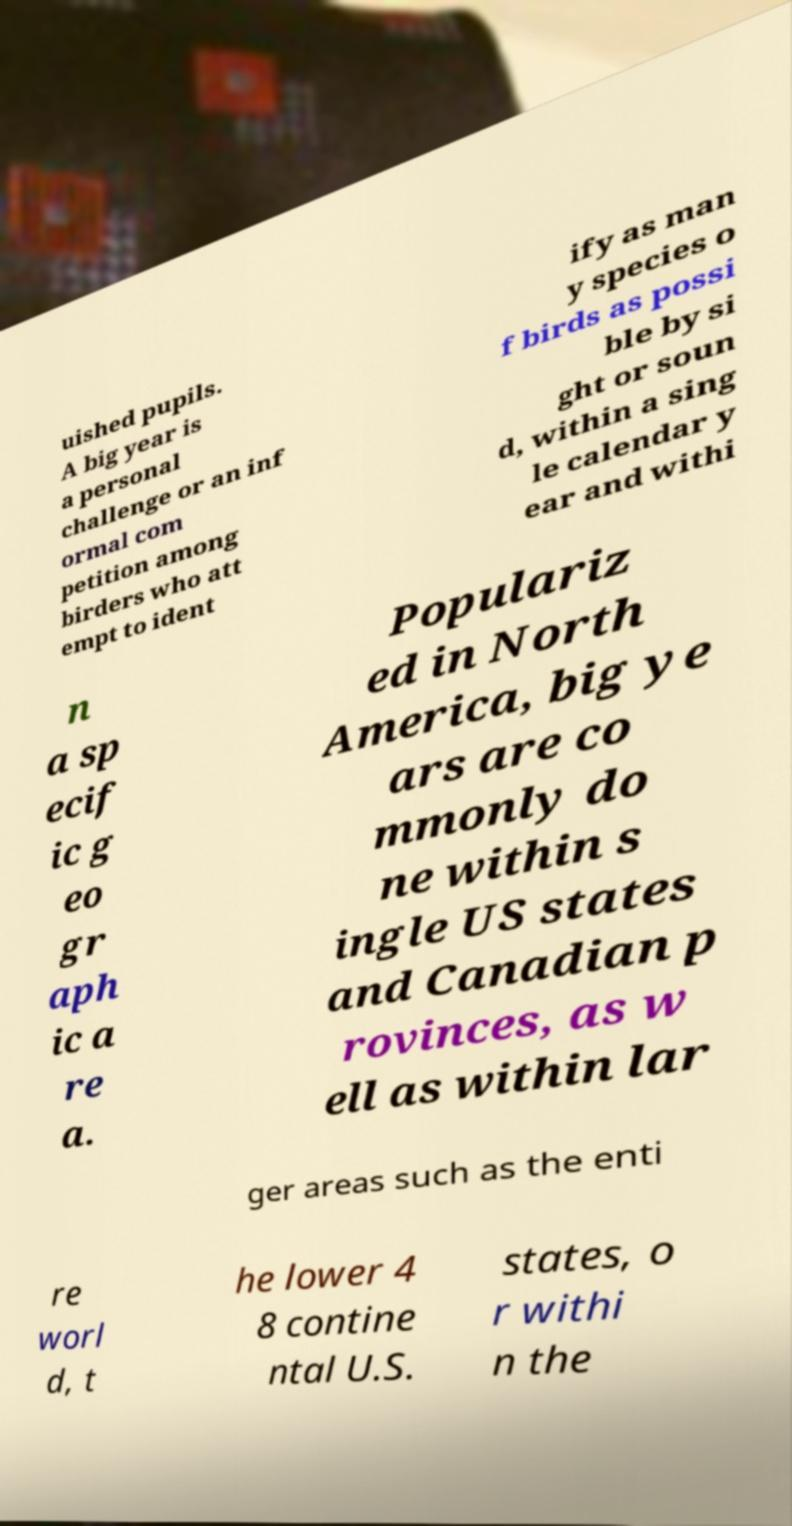What messages or text are displayed in this image? I need them in a readable, typed format. uished pupils. A big year is a personal challenge or an inf ormal com petition among birders who att empt to ident ify as man y species o f birds as possi ble by si ght or soun d, within a sing le calendar y ear and withi n a sp ecif ic g eo gr aph ic a re a. Populariz ed in North America, big ye ars are co mmonly do ne within s ingle US states and Canadian p rovinces, as w ell as within lar ger areas such as the enti re worl d, t he lower 4 8 contine ntal U.S. states, o r withi n the 